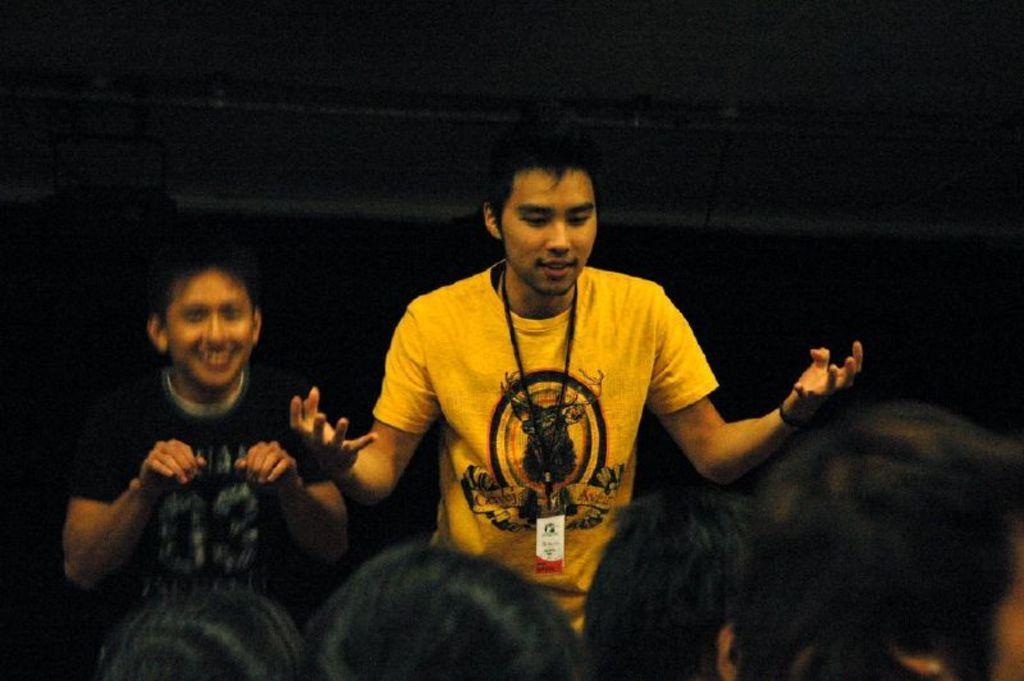In one or two sentences, can you explain what this image depicts? In this picture we can see two men standing here, a person on the right side wore a yellow color t-shirt, we can see some people's heads at the bottom. 